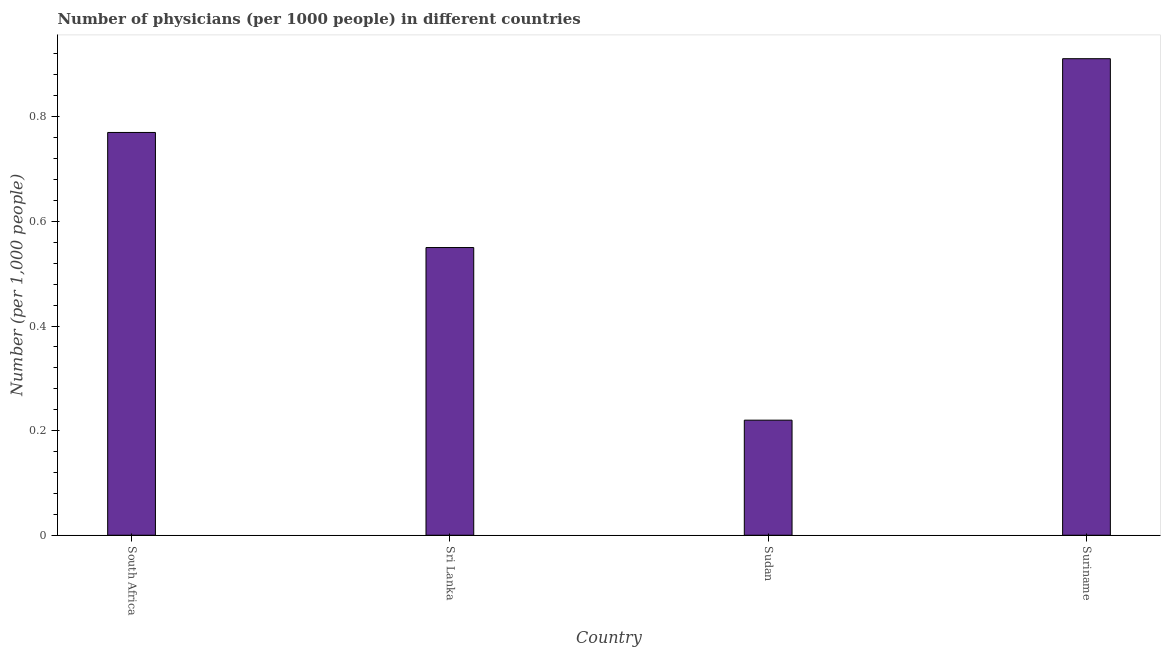Does the graph contain any zero values?
Provide a succinct answer. No. What is the title of the graph?
Ensure brevity in your answer.  Number of physicians (per 1000 people) in different countries. What is the label or title of the X-axis?
Provide a succinct answer. Country. What is the label or title of the Y-axis?
Your answer should be very brief. Number (per 1,0 people). What is the number of physicians in Sudan?
Your answer should be very brief. 0.22. Across all countries, what is the maximum number of physicians?
Provide a succinct answer. 0.91. Across all countries, what is the minimum number of physicians?
Ensure brevity in your answer.  0.22. In which country was the number of physicians maximum?
Make the answer very short. Suriname. In which country was the number of physicians minimum?
Make the answer very short. Sudan. What is the sum of the number of physicians?
Offer a very short reply. 2.45. What is the difference between the number of physicians in Sri Lanka and Sudan?
Offer a terse response. 0.33. What is the average number of physicians per country?
Make the answer very short. 0.61. What is the median number of physicians?
Keep it short and to the point. 0.66. What is the ratio of the number of physicians in Sri Lanka to that in Sudan?
Ensure brevity in your answer.  2.5. What is the difference between the highest and the second highest number of physicians?
Provide a succinct answer. 0.14. Is the sum of the number of physicians in Sri Lanka and Sudan greater than the maximum number of physicians across all countries?
Your answer should be very brief. No. What is the difference between the highest and the lowest number of physicians?
Keep it short and to the point. 0.69. In how many countries, is the number of physicians greater than the average number of physicians taken over all countries?
Your answer should be very brief. 2. How many bars are there?
Your answer should be very brief. 4. Are all the bars in the graph horizontal?
Offer a very short reply. No. What is the difference between two consecutive major ticks on the Y-axis?
Offer a very short reply. 0.2. What is the Number (per 1,000 people) of South Africa?
Provide a succinct answer. 0.77. What is the Number (per 1,000 people) of Sri Lanka?
Offer a very short reply. 0.55. What is the Number (per 1,000 people) of Sudan?
Offer a very short reply. 0.22. What is the Number (per 1,000 people) in Suriname?
Your answer should be very brief. 0.91. What is the difference between the Number (per 1,000 people) in South Africa and Sri Lanka?
Provide a short and direct response. 0.22. What is the difference between the Number (per 1,000 people) in South Africa and Sudan?
Ensure brevity in your answer.  0.55. What is the difference between the Number (per 1,000 people) in South Africa and Suriname?
Make the answer very short. -0.14. What is the difference between the Number (per 1,000 people) in Sri Lanka and Sudan?
Your answer should be very brief. 0.33. What is the difference between the Number (per 1,000 people) in Sri Lanka and Suriname?
Offer a very short reply. -0.36. What is the difference between the Number (per 1,000 people) in Sudan and Suriname?
Your response must be concise. -0.69. What is the ratio of the Number (per 1,000 people) in South Africa to that in Sri Lanka?
Offer a terse response. 1.4. What is the ratio of the Number (per 1,000 people) in South Africa to that in Suriname?
Ensure brevity in your answer.  0.84. What is the ratio of the Number (per 1,000 people) in Sri Lanka to that in Sudan?
Keep it short and to the point. 2.5. What is the ratio of the Number (per 1,000 people) in Sri Lanka to that in Suriname?
Keep it short and to the point. 0.6. What is the ratio of the Number (per 1,000 people) in Sudan to that in Suriname?
Make the answer very short. 0.24. 